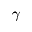<formula> <loc_0><loc_0><loc_500><loc_500>\gamma</formula> 